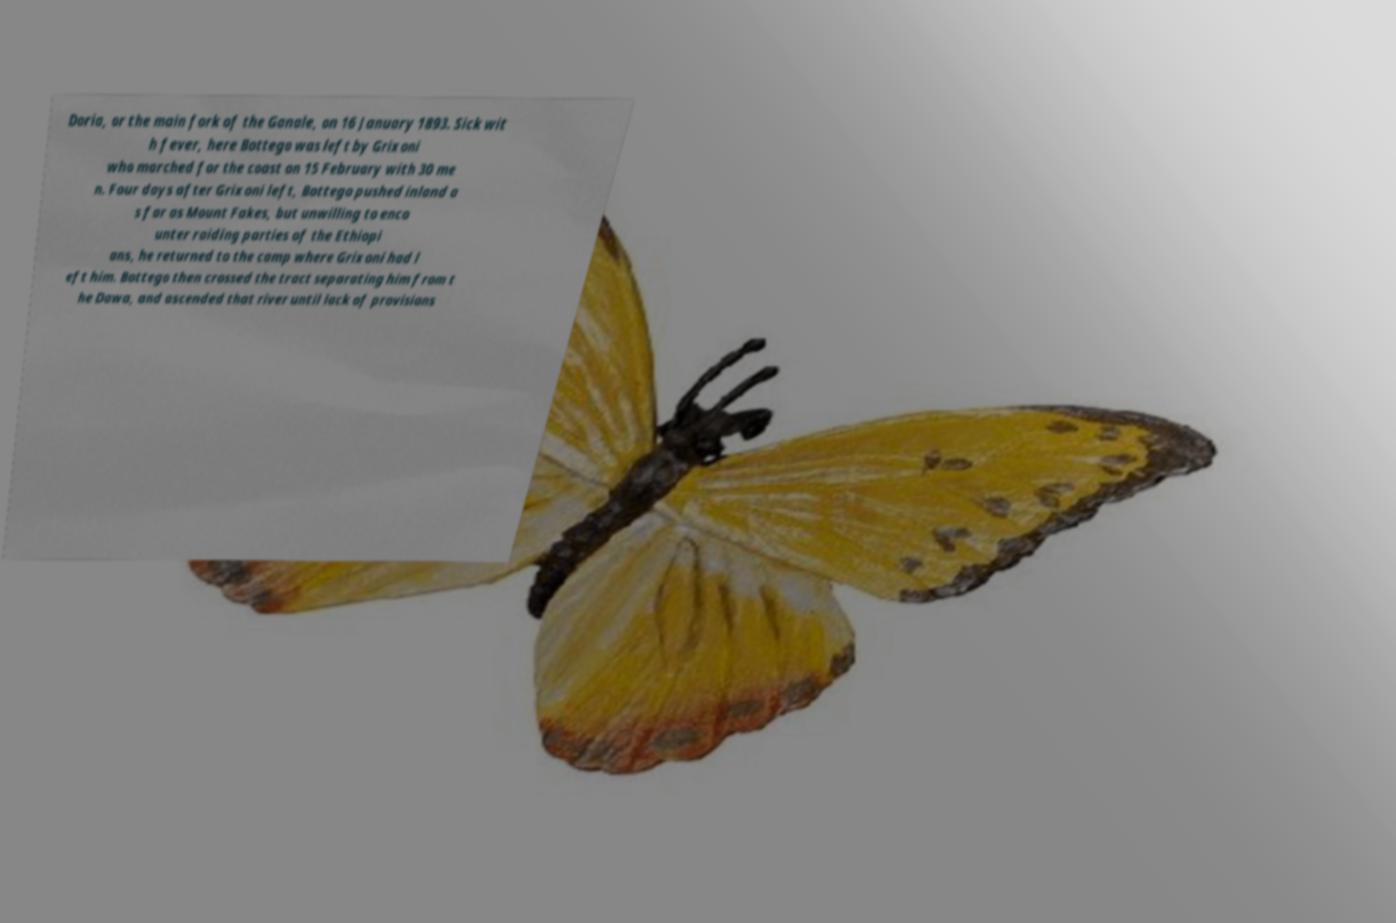Please identify and transcribe the text found in this image. Doria, or the main fork of the Ganale, on 16 January 1893. Sick wit h fever, here Bottego was left by Grixoni who marched for the coast on 15 February with 30 me n. Four days after Grixoni left, Bottego pushed inland a s far as Mount Fakes, but unwilling to enco unter raiding parties of the Ethiopi ans, he returned to the camp where Grixoni had l eft him. Bottego then crossed the tract separating him from t he Dawa, and ascended that river until lack of provisions 